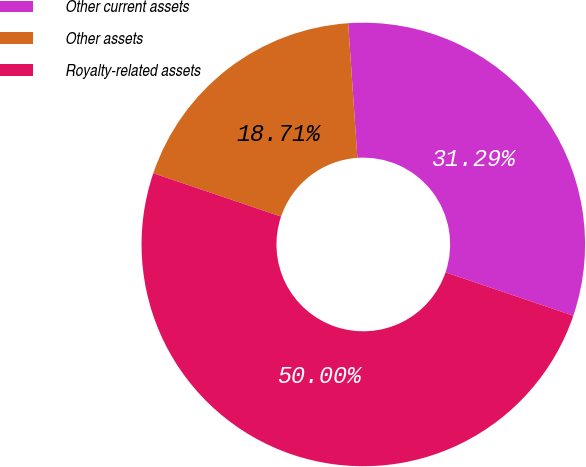Convert chart. <chart><loc_0><loc_0><loc_500><loc_500><pie_chart><fcel>Other current assets<fcel>Other assets<fcel>Royalty-related assets<nl><fcel>31.29%<fcel>18.71%<fcel>50.0%<nl></chart> 